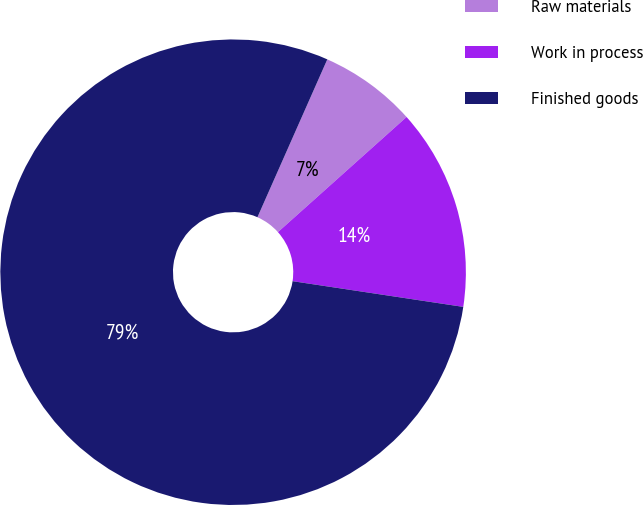Convert chart. <chart><loc_0><loc_0><loc_500><loc_500><pie_chart><fcel>Raw materials<fcel>Work in process<fcel>Finished goods<nl><fcel>6.75%<fcel>14.0%<fcel>79.26%<nl></chart> 